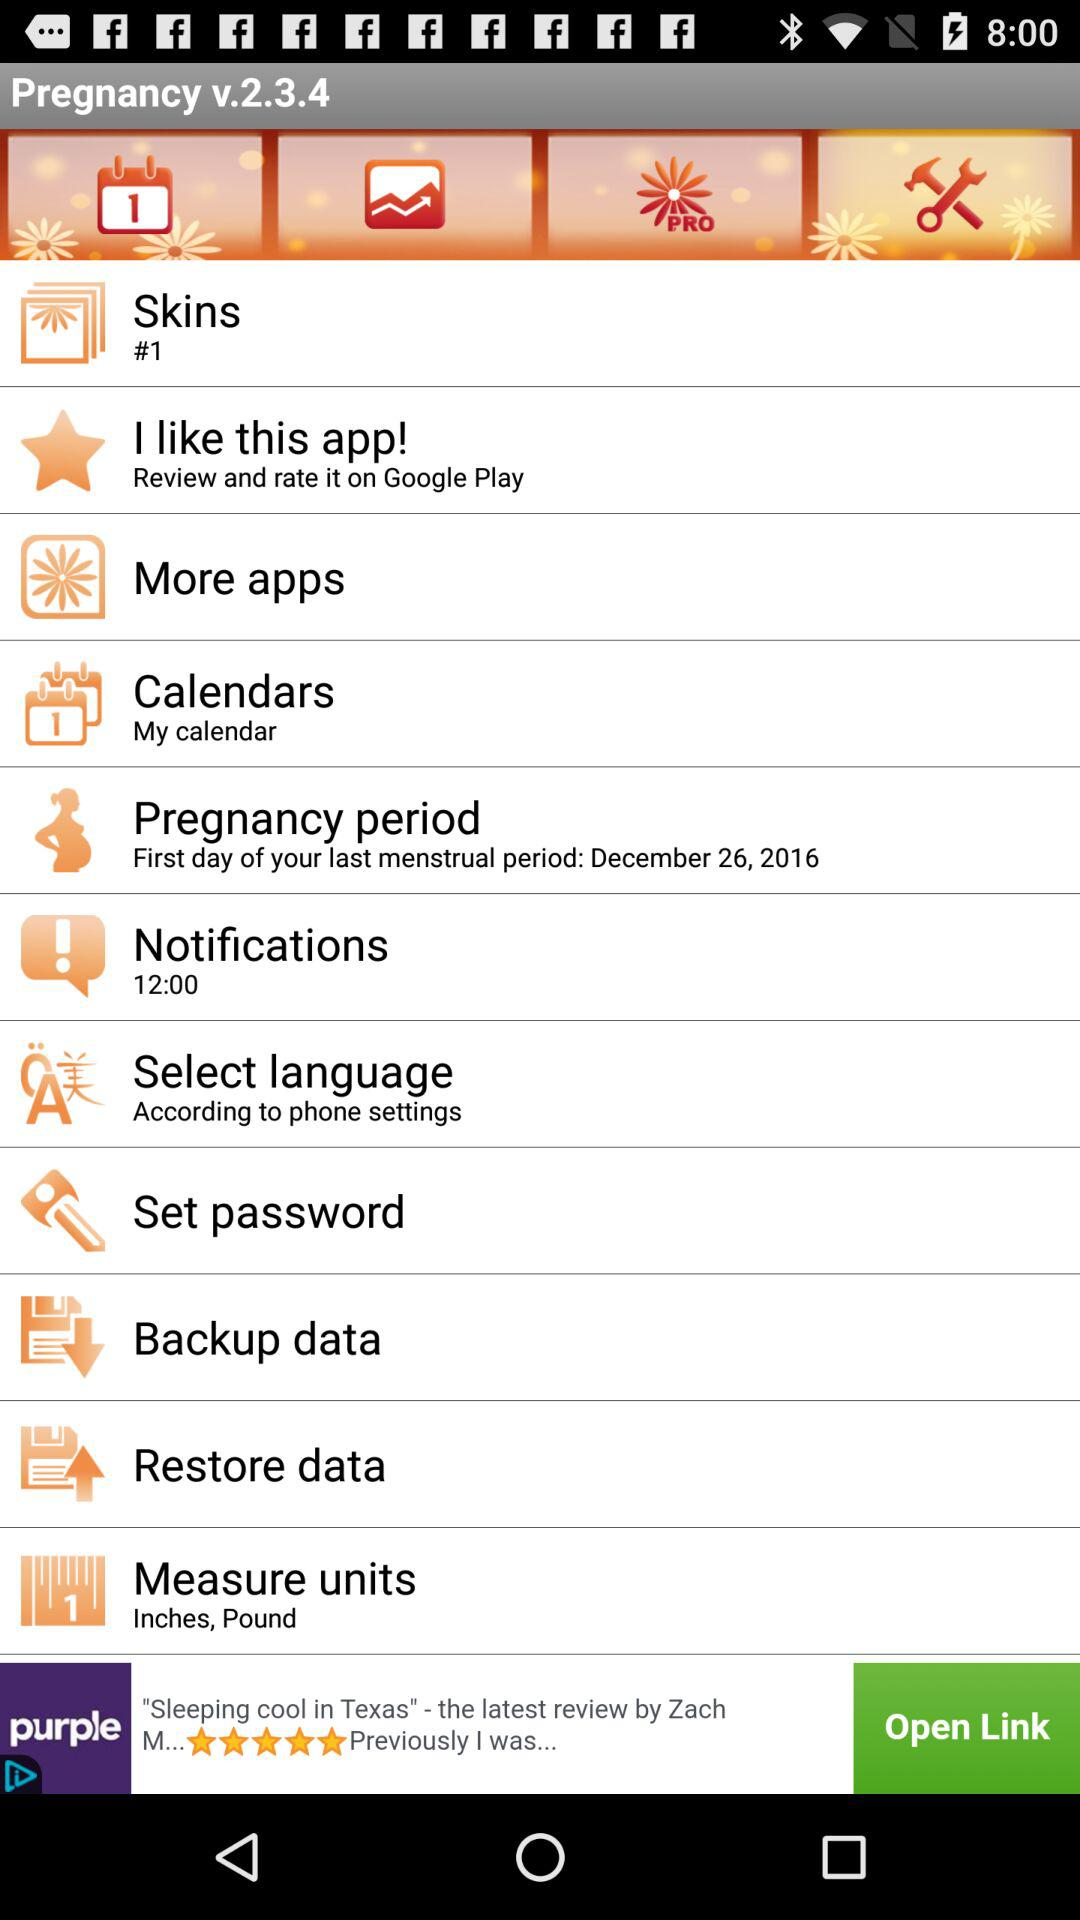What are the measuring units? The measuring units are inches and pounds. 